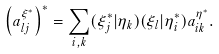<formula> <loc_0><loc_0><loc_500><loc_500>\left ( a ^ { \xi ^ { * } } _ { l j } \right ) ^ { * } = \sum _ { i , k } ( \xi _ { j } ^ { * } | \eta _ { k } ) ( \xi _ { l } | \eta ^ { * } _ { i } ) a ^ { \eta ^ { * } } _ { i k } .</formula> 